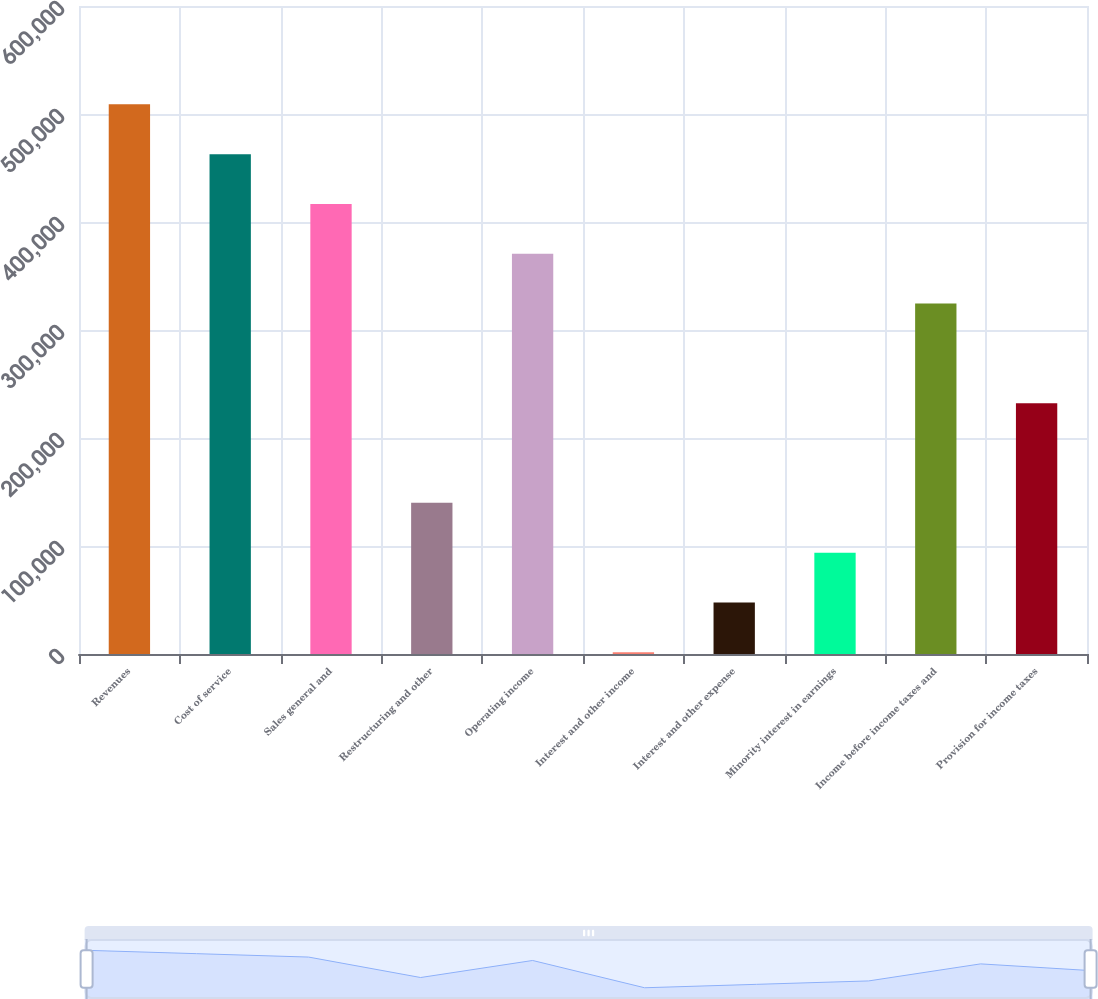Convert chart to OTSL. <chart><loc_0><loc_0><loc_500><loc_500><bar_chart><fcel>Revenues<fcel>Cost of service<fcel>Sales general and<fcel>Restructuring and other<fcel>Operating income<fcel>Interest and other income<fcel>Interest and other expense<fcel>Minority interest in earnings<fcel>Income before income taxes and<fcel>Provision for income taxes<nl><fcel>508949<fcel>462826<fcel>416703<fcel>139968<fcel>370581<fcel>1600<fcel>47722.6<fcel>93845.2<fcel>324458<fcel>232213<nl></chart> 